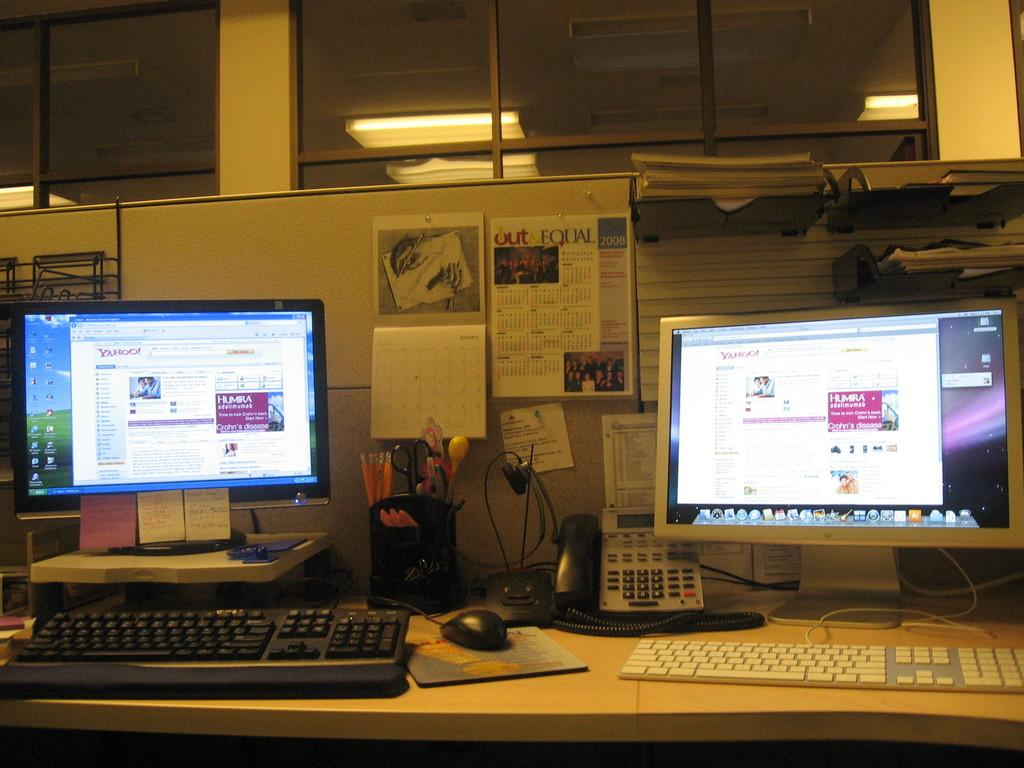<image>
Write a terse but informative summary of the picture. Two computers are on either side of an OUT & EQUAL wall calendar. 